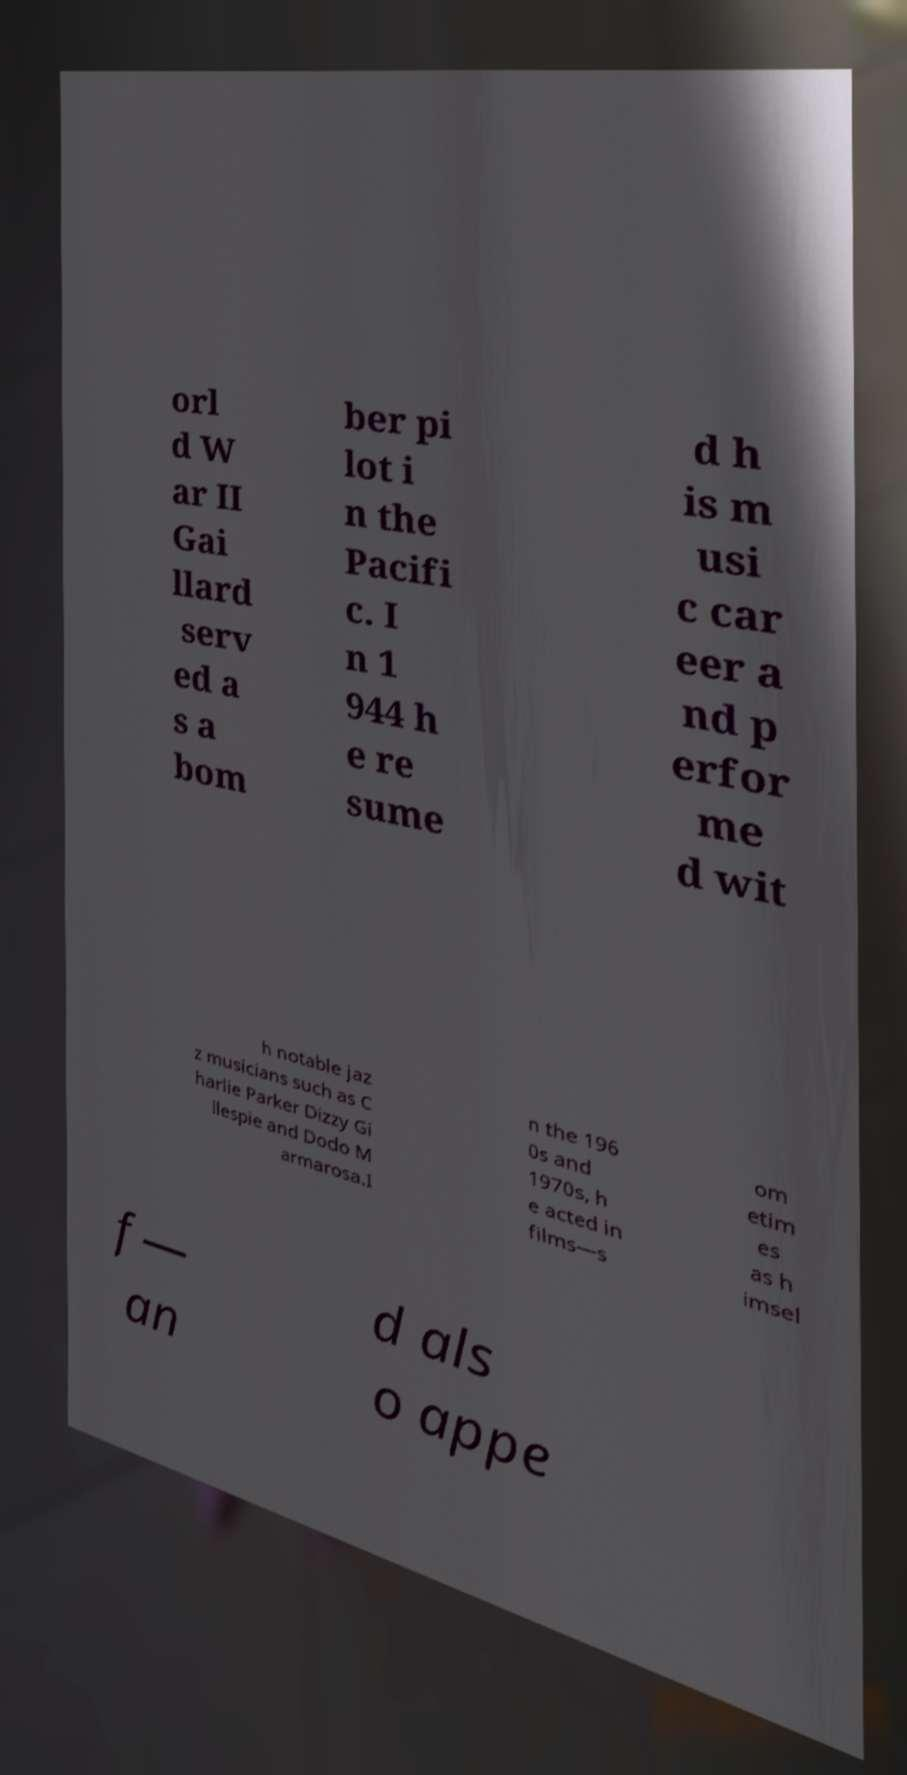Please identify and transcribe the text found in this image. orl d W ar II Gai llard serv ed a s a bom ber pi lot i n the Pacifi c. I n 1 944 h e re sume d h is m usi c car eer a nd p erfor me d wit h notable jaz z musicians such as C harlie Parker Dizzy Gi llespie and Dodo M armarosa.I n the 196 0s and 1970s, h e acted in films—s om etim es as h imsel f— an d als o appe 